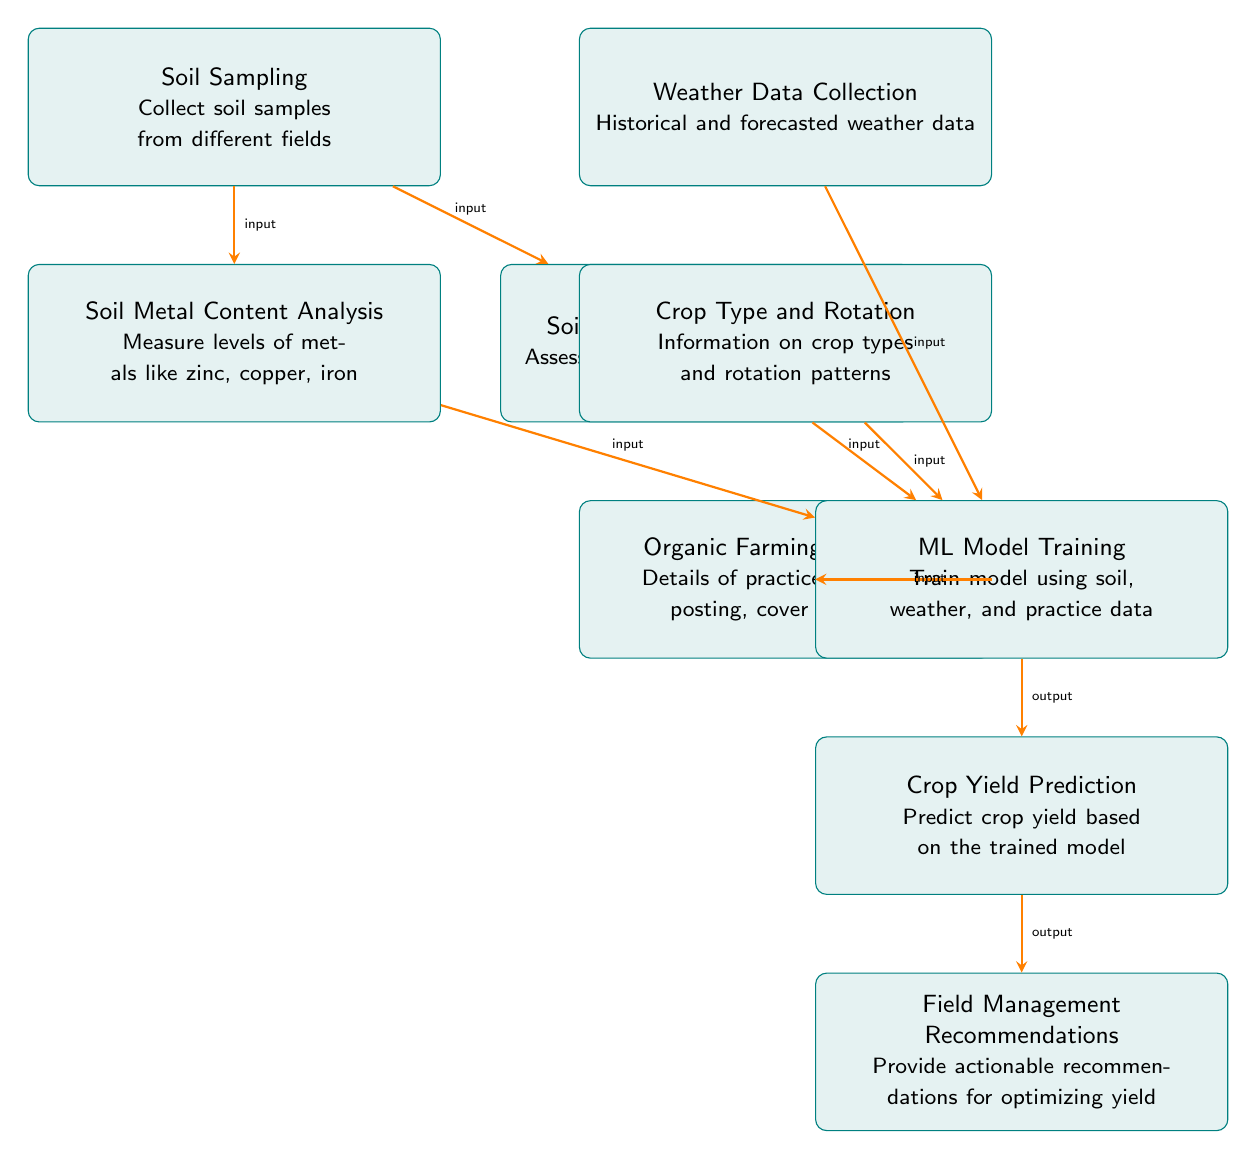What is the first step in the process? The first step in the process is Soil Sampling, where soil samples are collected from different fields. This is indicated by the first box in the diagram.
Answer: Soil Sampling How many input nodes are there? The diagram shows five input nodes: Soil Sampling, Weather Data Collection, Crop Type and Rotation, Organic Farming Practices, and Soil Metal Content Analysis. Counting these gives a total of five input nodes.
Answer: Five What is the output of the ML Model Training node? The output of the ML Model Training node is Crop Yield Prediction. This is shown by the arrow pointing from ML Model Training to Crop Yield Prediction in the diagram.
Answer: Crop Yield Prediction Which node provides actionable recommendations? The Field Management Recommendations node provides actionable recommendations for optimizing yield, as indicated by its position as the final output in the diagram.
Answer: Field Management Recommendations What is analyzed in the Soil Metal Content Analysis node? In the Soil Metal Content Analysis node, levels of metals like zinc, copper, and iron are measured. This is directly stated in the node's description.
Answer: Levels of metals like zinc, copper, iron What information does the Weather Data Collection node provide to the ML Model Training? The Weather Data Collection node provides historical and forecasted weather data, which is one of the inputs into the ML Model Training node. This information is required for the machine learning model to make informed predictions.
Answer: Historical and forecasted weather data Which nodes contribute data to the ML Model Training node? The nodes contributing data to the ML Model Training node are Soil Sampling, Soil Metal Content Analysis, Soil Organic Content Analysis, Weather Data Collection, Crop Type and Rotation, and Organic Farming Practices. These are all linked to the ML Model Training node by arrows.
Answer: Six nodes What is the sequence of processes leading to Crop Yield Prediction? The sequence is: Soil Sampling → Soil Metal Content Analysis → Soil Organic Content Analysis → Weather Data Collection → Crop Type and Rotation → Organic Farming Practices → ML Model Training → Crop Yield Prediction. This sequence follows the arrows in the diagram from inputs to outputs.
Answer: Soil Sampling → Soil Metal Content Analysis → Soil Organic Content Analysis → Weather Data Collection → Crop Type and Rotation → Organic Farming Practices → ML Model Training → Crop Yield Prediction How does the model provide recommendations for managing fields? The model provides recommendations for managing fields based on the output of Crop Yield Prediction, which uses training data from the previous processes. The recommendation step is directly after the prediction step, linking the predicted data to actionable insights.
Answer: By analyzing predicted crop yield 